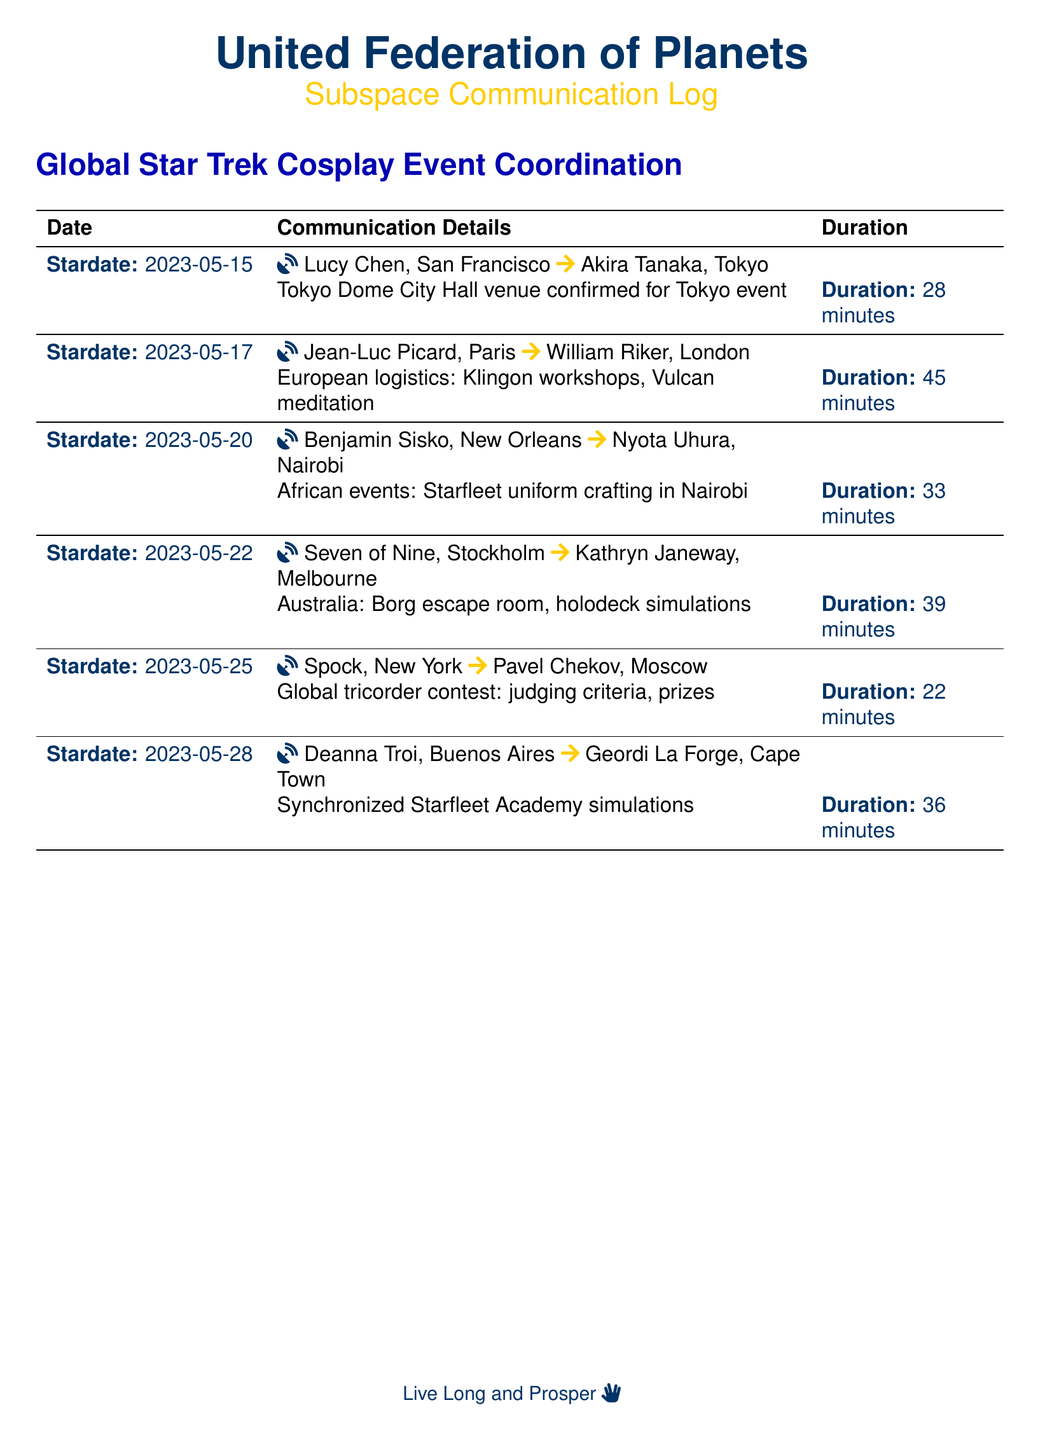What is the date of the first call? The first call in the document is on stardate 2023-05-15.
Answer: 2023-05-15 Who called from San Francisco? The call from San Francisco was made by Lucy Chen.
Answer: Lucy Chen What was discussed in the call on May 17? The call on May 17 involved European logistics for Klingon workshops and Vulcan meditation.
Answer: European logistics: Klingon workshops, Vulcan meditation How long did the call between Benjamin Sisko and Nyota Uhura last? The duration of the call between Benjamin Sisko and Nyota Uhura was 33 minutes.
Answer: 33 minutes Which two characters were involved in the discussion about a global tricorder contest? The characters in the global tricorder contest discussion were Spock and Pavel Chekov.
Answer: Spock and Pavel Chekov What event is taking place in Tokyo? The event happening in Tokyo is at the Tokyo Dome City Hall venue.
Answer: Tokyo Dome City Hall venue Which country was represented by Kathryn Janeway in the calls? Kathryn Janeway is representing Australia in the call details.
Answer: Australia What is the duration of the synchronized Starfleet Academy simulations call? The duration for the synchronized Starfleet Academy simulations call was 36 minutes.
Answer: 36 minutes What unique activity is mentioned for the Australian event? The Australian event features a Borg escape room and holodeck simulations.
Answer: Borg escape room, holodeck simulations 